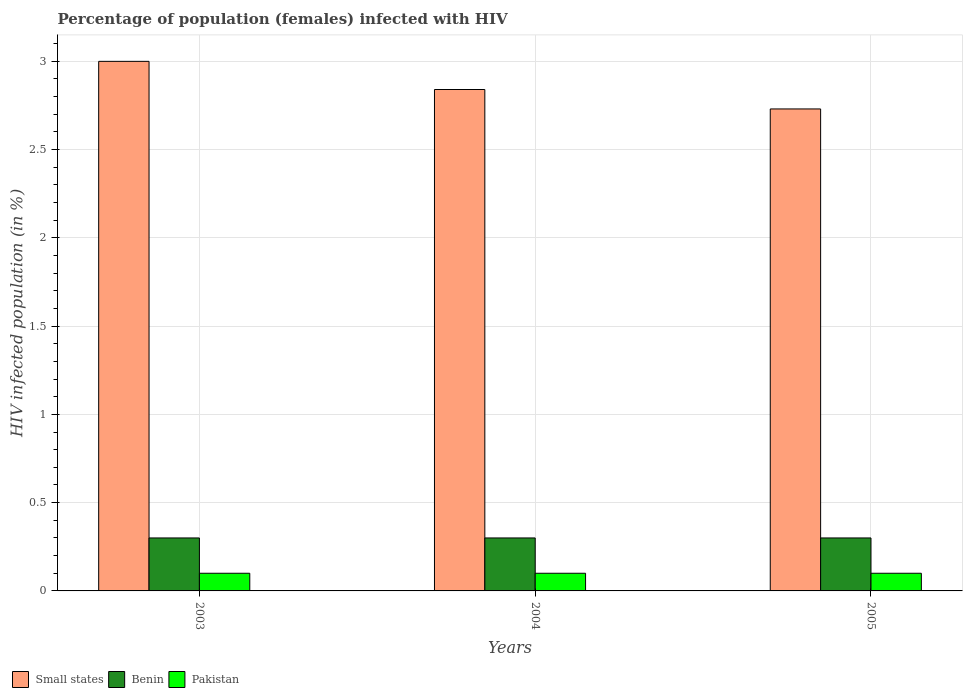How many groups of bars are there?
Your answer should be very brief. 3. Are the number of bars per tick equal to the number of legend labels?
Keep it short and to the point. Yes. Are the number of bars on each tick of the X-axis equal?
Offer a terse response. Yes. How many bars are there on the 1st tick from the left?
Provide a short and direct response. 3. What is the label of the 3rd group of bars from the left?
Ensure brevity in your answer.  2005. In how many cases, is the number of bars for a given year not equal to the number of legend labels?
Ensure brevity in your answer.  0. What is the percentage of HIV infected female population in Small states in 2003?
Provide a succinct answer. 3. Across all years, what is the maximum percentage of HIV infected female population in Small states?
Provide a succinct answer. 3. In which year was the percentage of HIV infected female population in Benin maximum?
Your answer should be compact. 2003. In which year was the percentage of HIV infected female population in Pakistan minimum?
Your answer should be very brief. 2003. What is the total percentage of HIV infected female population in Pakistan in the graph?
Make the answer very short. 0.3. What is the difference between the percentage of HIV infected female population in Pakistan in 2004 and that in 2005?
Ensure brevity in your answer.  0. What is the difference between the percentage of HIV infected female population in Small states in 2003 and the percentage of HIV infected female population in Pakistan in 2005?
Provide a succinct answer. 2.9. What is the average percentage of HIV infected female population in Pakistan per year?
Keep it short and to the point. 0.1. In the year 2004, what is the difference between the percentage of HIV infected female population in Benin and percentage of HIV infected female population in Pakistan?
Ensure brevity in your answer.  0.2. In how many years, is the percentage of HIV infected female population in Pakistan greater than 2.3 %?
Offer a very short reply. 0. Is the percentage of HIV infected female population in Small states in 2003 less than that in 2005?
Your answer should be very brief. No. What is the difference between the highest and the second highest percentage of HIV infected female population in Pakistan?
Keep it short and to the point. 0. In how many years, is the percentage of HIV infected female population in Pakistan greater than the average percentage of HIV infected female population in Pakistan taken over all years?
Provide a short and direct response. 0. What does the 2nd bar from the left in 2004 represents?
Make the answer very short. Benin. What does the 3rd bar from the right in 2004 represents?
Provide a succinct answer. Small states. Is it the case that in every year, the sum of the percentage of HIV infected female population in Small states and percentage of HIV infected female population in Pakistan is greater than the percentage of HIV infected female population in Benin?
Give a very brief answer. Yes. How many years are there in the graph?
Your answer should be very brief. 3. What is the difference between two consecutive major ticks on the Y-axis?
Keep it short and to the point. 0.5. Does the graph contain any zero values?
Your answer should be very brief. No. Does the graph contain grids?
Keep it short and to the point. Yes. Where does the legend appear in the graph?
Keep it short and to the point. Bottom left. How many legend labels are there?
Offer a terse response. 3. What is the title of the graph?
Make the answer very short. Percentage of population (females) infected with HIV. Does "Cuba" appear as one of the legend labels in the graph?
Your answer should be compact. No. What is the label or title of the X-axis?
Provide a succinct answer. Years. What is the label or title of the Y-axis?
Ensure brevity in your answer.  HIV infected population (in %). What is the HIV infected population (in %) of Small states in 2003?
Make the answer very short. 3. What is the HIV infected population (in %) in Benin in 2003?
Provide a short and direct response. 0.3. What is the HIV infected population (in %) in Pakistan in 2003?
Your response must be concise. 0.1. What is the HIV infected population (in %) in Small states in 2004?
Your answer should be very brief. 2.84. What is the HIV infected population (in %) in Benin in 2004?
Make the answer very short. 0.3. What is the HIV infected population (in %) in Small states in 2005?
Your response must be concise. 2.73. Across all years, what is the maximum HIV infected population (in %) in Small states?
Offer a terse response. 3. Across all years, what is the maximum HIV infected population (in %) in Benin?
Your answer should be compact. 0.3. Across all years, what is the maximum HIV infected population (in %) in Pakistan?
Provide a succinct answer. 0.1. Across all years, what is the minimum HIV infected population (in %) of Small states?
Ensure brevity in your answer.  2.73. Across all years, what is the minimum HIV infected population (in %) in Pakistan?
Provide a short and direct response. 0.1. What is the total HIV infected population (in %) in Small states in the graph?
Provide a short and direct response. 8.57. What is the total HIV infected population (in %) in Benin in the graph?
Your answer should be very brief. 0.9. What is the difference between the HIV infected population (in %) in Small states in 2003 and that in 2004?
Offer a very short reply. 0.16. What is the difference between the HIV infected population (in %) in Benin in 2003 and that in 2004?
Your response must be concise. 0. What is the difference between the HIV infected population (in %) of Small states in 2003 and that in 2005?
Your answer should be very brief. 0.27. What is the difference between the HIV infected population (in %) in Pakistan in 2003 and that in 2005?
Your answer should be very brief. 0. What is the difference between the HIV infected population (in %) of Small states in 2004 and that in 2005?
Give a very brief answer. 0.11. What is the difference between the HIV infected population (in %) of Pakistan in 2004 and that in 2005?
Your answer should be compact. 0. What is the difference between the HIV infected population (in %) of Small states in 2003 and the HIV infected population (in %) of Benin in 2004?
Your answer should be very brief. 2.7. What is the difference between the HIV infected population (in %) in Small states in 2003 and the HIV infected population (in %) in Pakistan in 2004?
Give a very brief answer. 2.9. What is the difference between the HIV infected population (in %) of Benin in 2003 and the HIV infected population (in %) of Pakistan in 2004?
Your answer should be compact. 0.2. What is the difference between the HIV infected population (in %) in Small states in 2003 and the HIV infected population (in %) in Benin in 2005?
Your response must be concise. 2.7. What is the difference between the HIV infected population (in %) of Small states in 2003 and the HIV infected population (in %) of Pakistan in 2005?
Offer a very short reply. 2.9. What is the difference between the HIV infected population (in %) of Benin in 2003 and the HIV infected population (in %) of Pakistan in 2005?
Offer a terse response. 0.2. What is the difference between the HIV infected population (in %) of Small states in 2004 and the HIV infected population (in %) of Benin in 2005?
Your answer should be compact. 2.54. What is the difference between the HIV infected population (in %) of Small states in 2004 and the HIV infected population (in %) of Pakistan in 2005?
Make the answer very short. 2.74. What is the average HIV infected population (in %) of Small states per year?
Give a very brief answer. 2.86. What is the average HIV infected population (in %) of Pakistan per year?
Offer a terse response. 0.1. In the year 2003, what is the difference between the HIV infected population (in %) of Small states and HIV infected population (in %) of Benin?
Offer a terse response. 2.7. In the year 2003, what is the difference between the HIV infected population (in %) in Small states and HIV infected population (in %) in Pakistan?
Your response must be concise. 2.9. In the year 2003, what is the difference between the HIV infected population (in %) of Benin and HIV infected population (in %) of Pakistan?
Make the answer very short. 0.2. In the year 2004, what is the difference between the HIV infected population (in %) of Small states and HIV infected population (in %) of Benin?
Provide a succinct answer. 2.54. In the year 2004, what is the difference between the HIV infected population (in %) in Small states and HIV infected population (in %) in Pakistan?
Your response must be concise. 2.74. In the year 2005, what is the difference between the HIV infected population (in %) of Small states and HIV infected population (in %) of Benin?
Your answer should be very brief. 2.43. In the year 2005, what is the difference between the HIV infected population (in %) of Small states and HIV infected population (in %) of Pakistan?
Keep it short and to the point. 2.63. What is the ratio of the HIV infected population (in %) in Small states in 2003 to that in 2004?
Keep it short and to the point. 1.06. What is the ratio of the HIV infected population (in %) of Benin in 2003 to that in 2004?
Give a very brief answer. 1. What is the ratio of the HIV infected population (in %) of Small states in 2003 to that in 2005?
Ensure brevity in your answer.  1.1. What is the ratio of the HIV infected population (in %) in Pakistan in 2003 to that in 2005?
Provide a short and direct response. 1. What is the ratio of the HIV infected population (in %) of Small states in 2004 to that in 2005?
Give a very brief answer. 1.04. What is the ratio of the HIV infected population (in %) of Pakistan in 2004 to that in 2005?
Keep it short and to the point. 1. What is the difference between the highest and the second highest HIV infected population (in %) in Small states?
Keep it short and to the point. 0.16. What is the difference between the highest and the lowest HIV infected population (in %) of Small states?
Make the answer very short. 0.27. What is the difference between the highest and the lowest HIV infected population (in %) in Pakistan?
Keep it short and to the point. 0. 